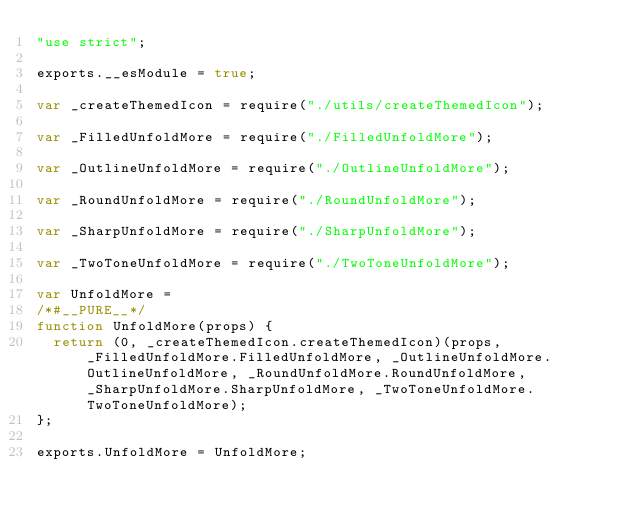Convert code to text. <code><loc_0><loc_0><loc_500><loc_500><_JavaScript_>"use strict";

exports.__esModule = true;

var _createThemedIcon = require("./utils/createThemedIcon");

var _FilledUnfoldMore = require("./FilledUnfoldMore");

var _OutlineUnfoldMore = require("./OutlineUnfoldMore");

var _RoundUnfoldMore = require("./RoundUnfoldMore");

var _SharpUnfoldMore = require("./SharpUnfoldMore");

var _TwoToneUnfoldMore = require("./TwoToneUnfoldMore");

var UnfoldMore =
/*#__PURE__*/
function UnfoldMore(props) {
  return (0, _createThemedIcon.createThemedIcon)(props, _FilledUnfoldMore.FilledUnfoldMore, _OutlineUnfoldMore.OutlineUnfoldMore, _RoundUnfoldMore.RoundUnfoldMore, _SharpUnfoldMore.SharpUnfoldMore, _TwoToneUnfoldMore.TwoToneUnfoldMore);
};

exports.UnfoldMore = UnfoldMore;</code> 